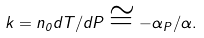Convert formula to latex. <formula><loc_0><loc_0><loc_500><loc_500>k = n _ { 0 } d T / d P \cong - \alpha _ { P } / \alpha .</formula> 